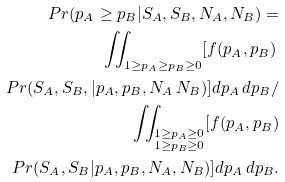Convert formula to latex. <formula><loc_0><loc_0><loc_500><loc_500>P r ( p _ { A } \geq p _ { B } | S _ { A } , S _ { B } , N _ { A } , N _ { B } ) = \\ { } \iint _ { \substack { 1 \geq p _ { A } \geq p _ { B } \geq 0 } } [ f ( p _ { A } , p _ { B } ) \, \\ P r ( S _ { A } , S _ { B } , | p _ { A } , p _ { B } , N _ { A } \, N _ { B } ) ] d p _ { A } \, d p _ { B } / \\ \quad { } \iint _ { \substack { 1 \geq p _ { A } \geq 0 \\ 1 \geq p _ { B } \geq 0 } } [ f ( p _ { A } , p _ { B } ) \\ P r ( S _ { A } , S _ { B } | p _ { A } , p _ { B } , N _ { A } , N _ { B } ) ] d p _ { A } \, d p _ { B } .</formula> 